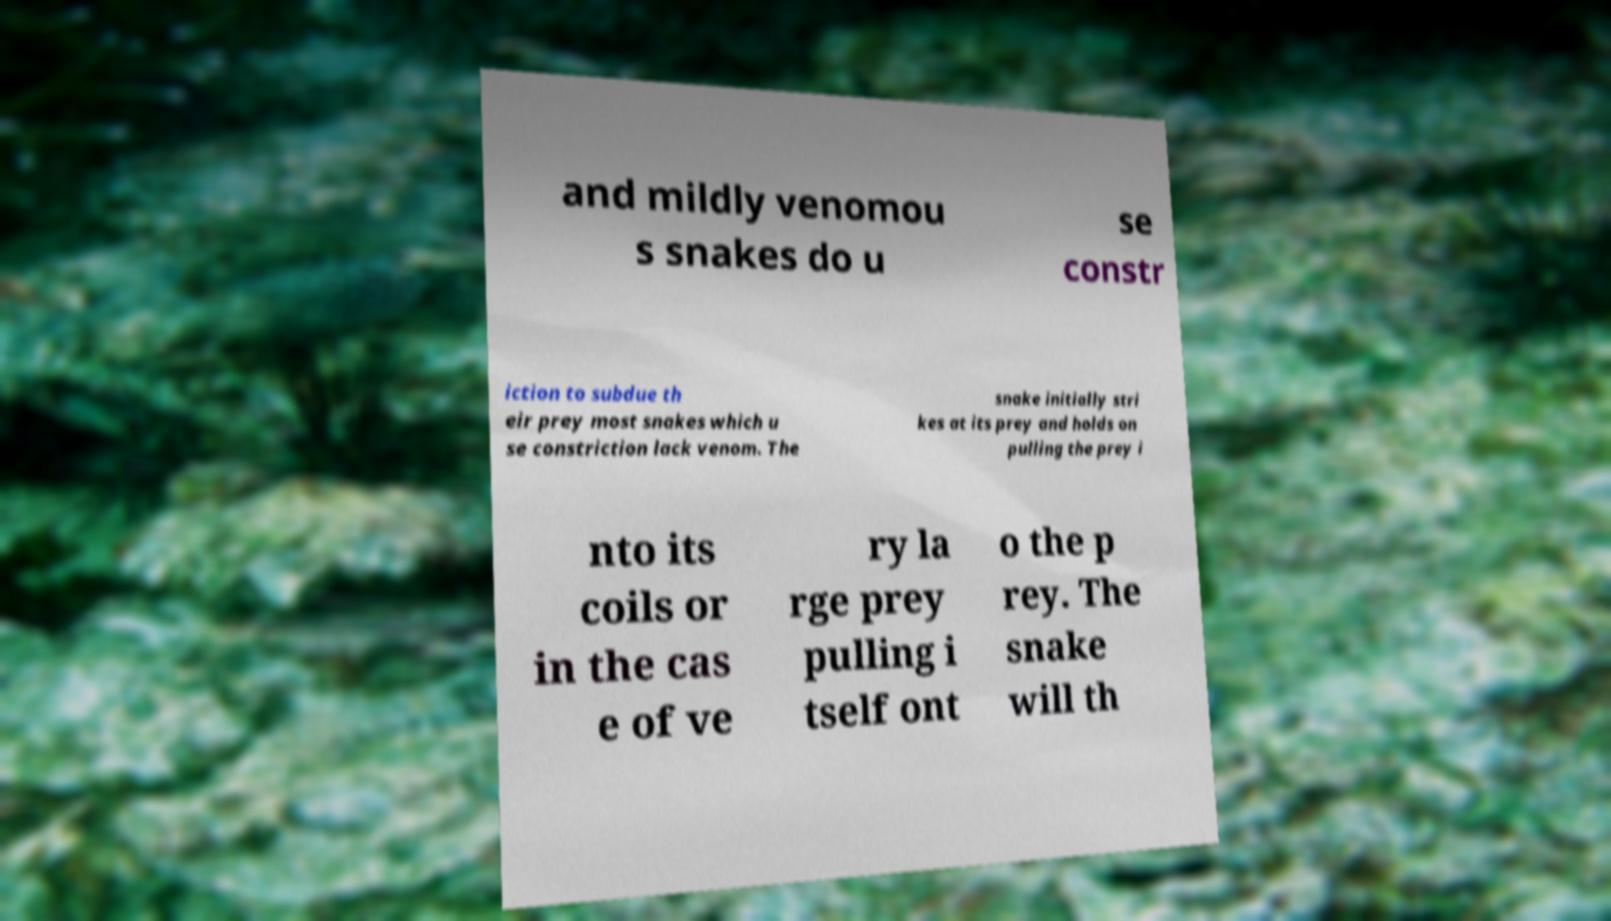Can you read and provide the text displayed in the image?This photo seems to have some interesting text. Can you extract and type it out for me? and mildly venomou s snakes do u se constr iction to subdue th eir prey most snakes which u se constriction lack venom. The snake initially stri kes at its prey and holds on pulling the prey i nto its coils or in the cas e of ve ry la rge prey pulling i tself ont o the p rey. The snake will th 